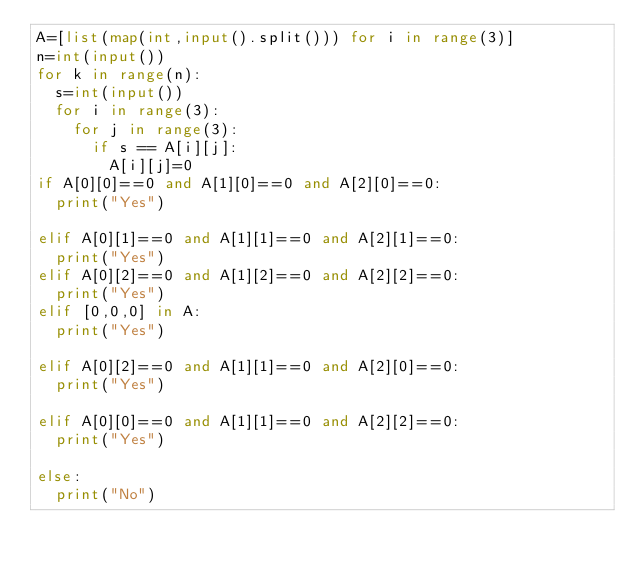Convert code to text. <code><loc_0><loc_0><loc_500><loc_500><_Python_>A=[list(map(int,input().split())) for i in range(3)]
n=int(input())
for k in range(n):
  s=int(input())
  for i in range(3):
    for j in range(3):
      if s == A[i][j]:
        A[i][j]=0   
if A[0][0]==0 and A[1][0]==0 and A[2][0]==0:
  print("Yes")
   
elif A[0][1]==0 and A[1][1]==0 and A[2][1]==0:
  print("Yes")
elif A[0][2]==0 and A[1][2]==0 and A[2][2]==0:
  print("Yes")
elif [0,0,0] in A:
  print("Yes")
  
elif A[0][2]==0 and A[1][1]==0 and A[2][0]==0:
  print("Yes")
  
elif A[0][0]==0 and A[1][1]==0 and A[2][2]==0:
  print("Yes")
  
else:
  print("No")</code> 